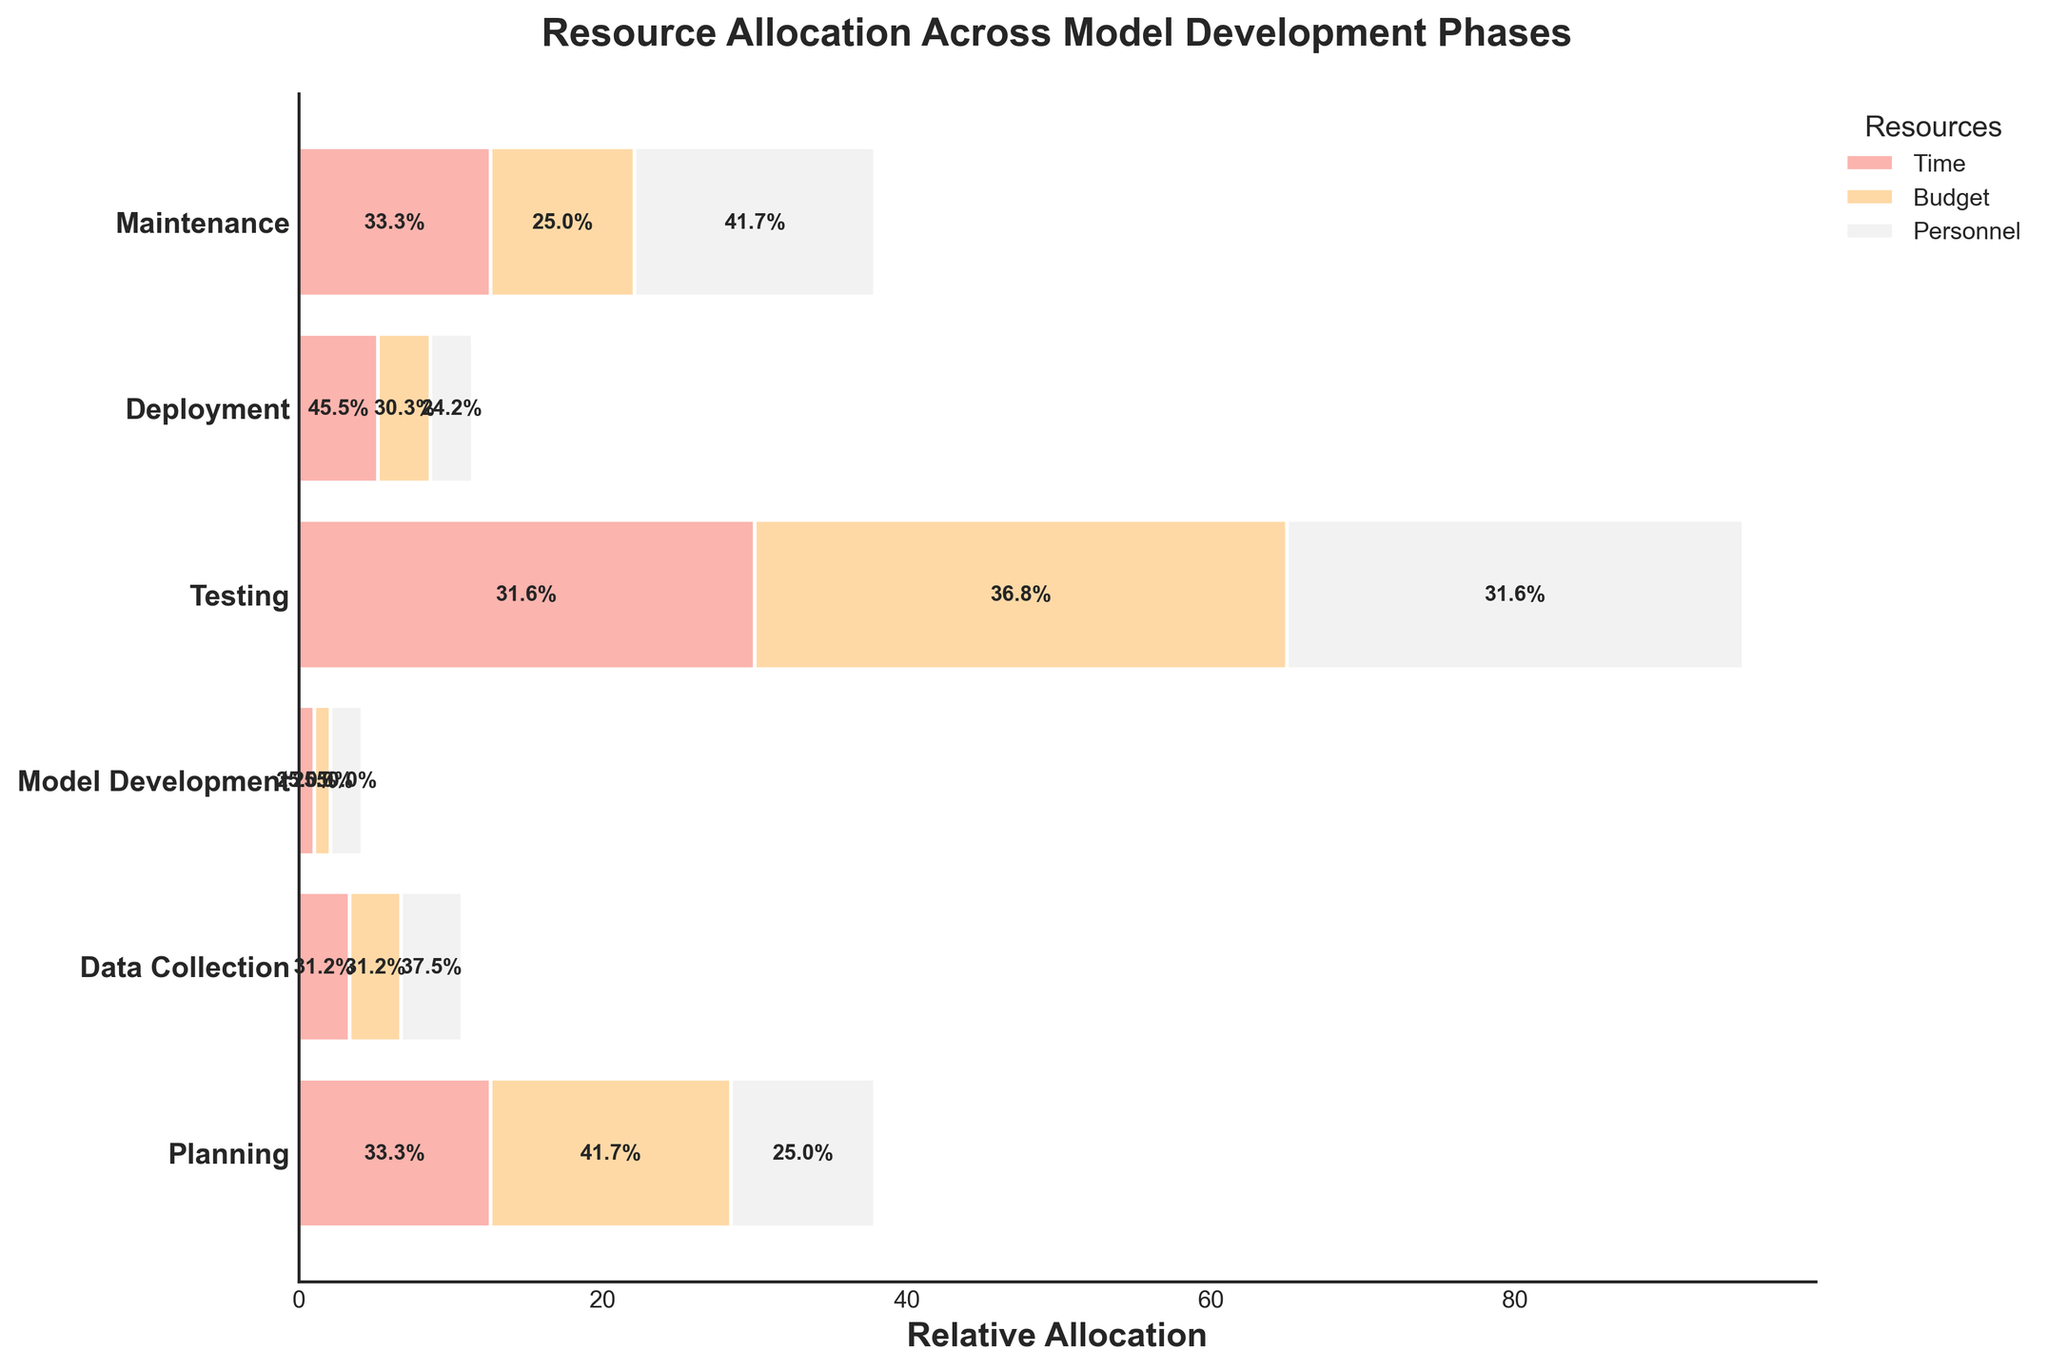Which phase has the highest allocation of budget? By looking at the widths of the bars representing the budget allocation, we can identify the phase with the widest bar.
Answer: Model Development Which resource has the smallest allocation during the Deployment phase? By comparing the width of the bars within the Deployment phase, the narrowest bar corresponds to the resource with the smallest allocation.
Answer: Time and Budget What percentage of the total allocation in the Testing phase is dedicated to personnel? In the Testing phase, the bar representing Personnel has a specific width. The exact percentage is labelled on the bar within the plot.
Answer: 37.5% How does the allocation of time in the Planning phase compare to the Deployment phase? By comparing the widths of the time bars in the Planning and Deployment phases, we can see how they differ.
Answer: Planning has a larger allocation Which phase has the most balanced resource allocation? By visually assessing the relative widths of the bars within each phase, the phase where all bars are most similar in width is the most balanced.
Answer: Deployment How do the allocations of budget in the Data Collection and Testing phases compare? By comparing the widths of the budget bars in the Data Collection and Testing phases, we can identify which phase has a larger or smaller allocation.
Answer: Data Collection has a larger allocation What is the title of the plot? The title is visually located at the top of the plot, describing its content.
Answer: Resource Allocation Across Model Development Phases What phase has the least allocation of time? By looking at the heights of the bars representing time allocation across all phases, the shortest bar indicates the phase with the least allocation.
Answer: Maintenance If we sum the allocations of personnel for Data Collection and Model Development phases, what is the result? Adding the personnel allocation values from Data Collection (15) and Model Development (30) gives us the total.
Answer: 45 Which resource shows the highest allocation percentage in the Model Development phase? In the Model Development phase, the resource with the widest bar and the highest percentage label indicates the highest allocation.
Answer: Budget 